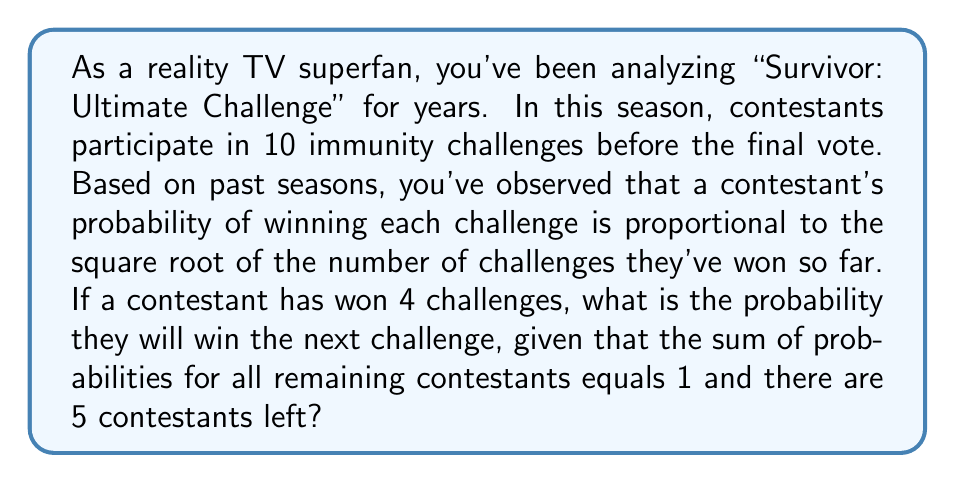Solve this math problem. Let's approach this step-by-step:

1) Let's define $p_i$ as the probability of contestant $i$ winning the next challenge.

2) We're told that the probability is proportional to the square root of the number of challenges won. Let's call this constant of proportionality $k$. So for our contestant of interest:

   $p_1 = k\sqrt{4} = 2k$

3) For the other four contestants, we don't know how many challenges they've won, but we can represent their probabilities as:

   $p_2 = k\sqrt{a}$, $p_3 = k\sqrt{b}$, $p_4 = k\sqrt{c}$, $p_5 = k\sqrt{d}$

   Where $a$, $b$, $c$, and $d$ are the number of challenges won by each contestant.

4) We're told that the sum of all probabilities equals 1:

   $p_1 + p_2 + p_3 + p_4 + p_5 = 1$

5) Substituting our expressions:

   $2k + k\sqrt{a} + k\sqrt{b} + k\sqrt{c} + k\sqrt{d} = 1$

6) Factor out $k$:

   $k(2 + \sqrt{a} + \sqrt{b} + \sqrt{c} + \sqrt{d}) = 1$

7) Solve for $k$:

   $k = \frac{1}{2 + \sqrt{a} + \sqrt{b} + \sqrt{c} + \sqrt{d}}$

8) The probability we're looking for is $p_1 = 2k$, so:

   $p_1 = \frac{2}{2 + \sqrt{a} + \sqrt{b} + \sqrt{c} + \sqrt{d}}$

9) We don't know the values of $a$, $b$, $c$, and $d$, but we know they must sum to 6 (because 10 total challenges have been played, and our contestant has won 4). The expression $\sqrt{a} + \sqrt{b} + \sqrt{c} + \sqrt{d}$ will be minimized when $a = b = c = d = 1.5$ (although this isn't possible in reality, it gives us a lower bound).

10) Therefore:

    $p_1 \geq \frac{2}{2 + 4\sqrt{1.5}} \approx 0.3478$

This is the minimum probability. The actual probability could be higher depending on the distribution of wins among the other contestants.
Answer: The probability that the contestant will win the next challenge is at least $\frac{2}{2 + 4\sqrt{1.5}} \approx 0.3478$ or 34.78%. 